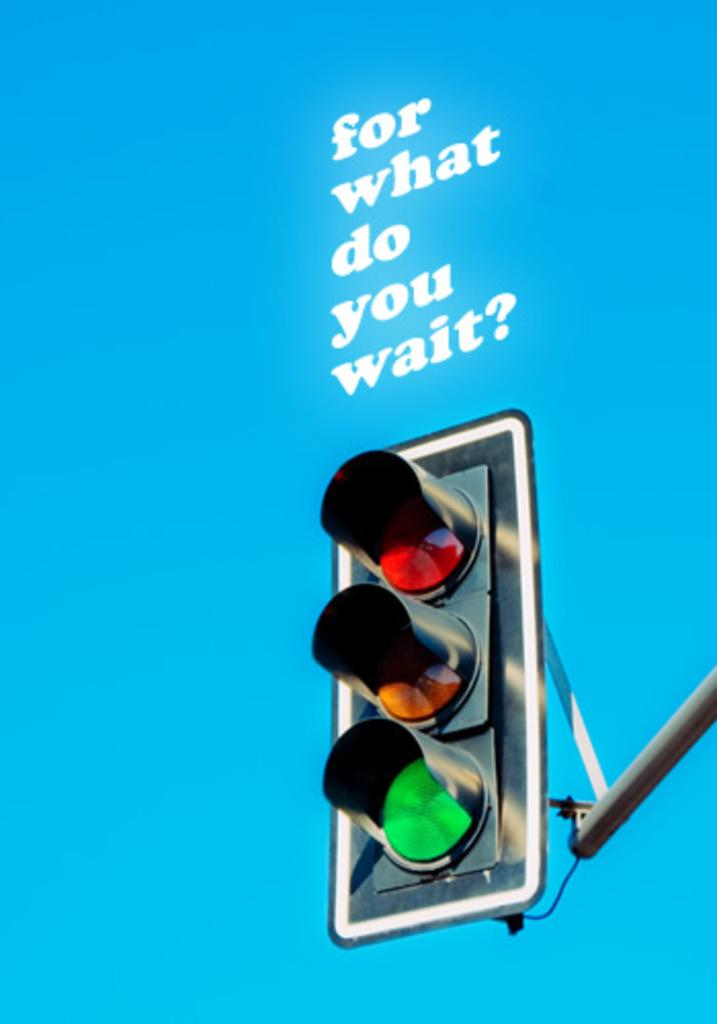<image>
Provide a brief description of the given image. a blue poster that says 'for what do you wait?' above a traffic light 